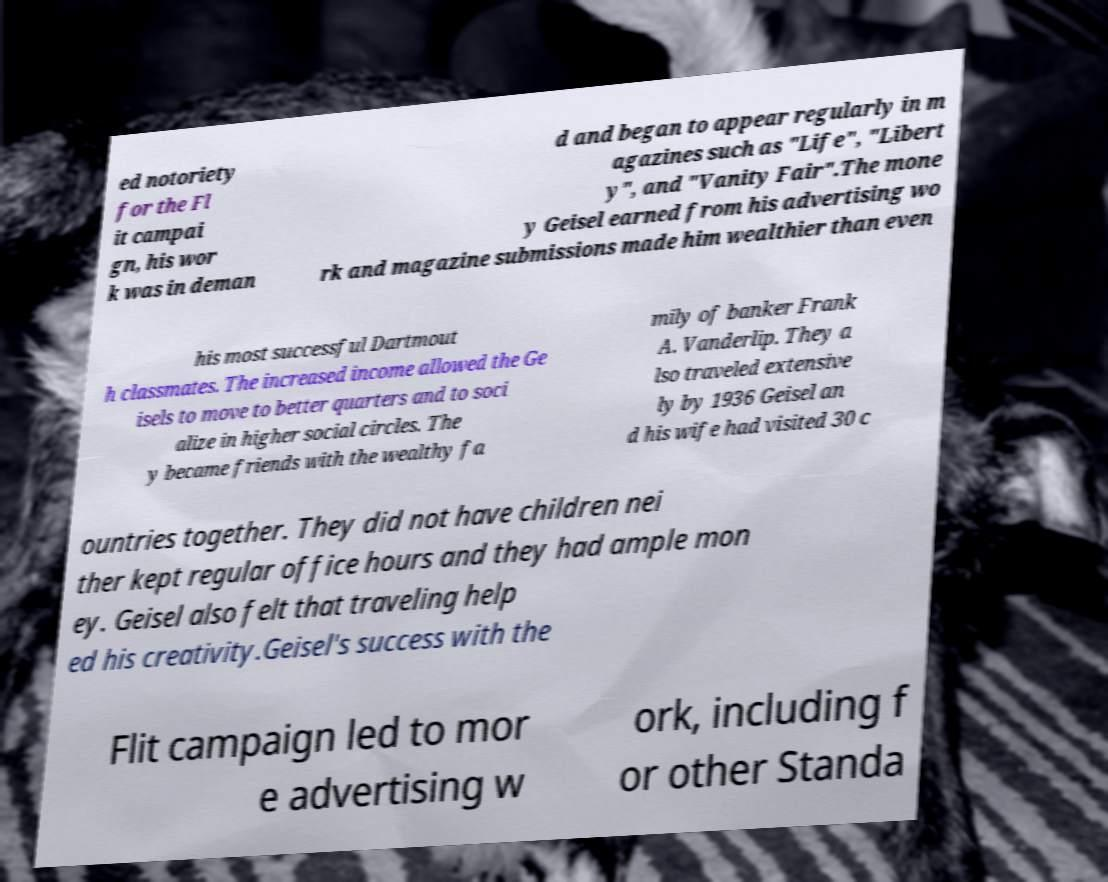For documentation purposes, I need the text within this image transcribed. Could you provide that? ed notoriety for the Fl it campai gn, his wor k was in deman d and began to appear regularly in m agazines such as "Life", "Libert y", and "Vanity Fair".The mone y Geisel earned from his advertising wo rk and magazine submissions made him wealthier than even his most successful Dartmout h classmates. The increased income allowed the Ge isels to move to better quarters and to soci alize in higher social circles. The y became friends with the wealthy fa mily of banker Frank A. Vanderlip. They a lso traveled extensive ly by 1936 Geisel an d his wife had visited 30 c ountries together. They did not have children nei ther kept regular office hours and they had ample mon ey. Geisel also felt that traveling help ed his creativity.Geisel's success with the Flit campaign led to mor e advertising w ork, including f or other Standa 